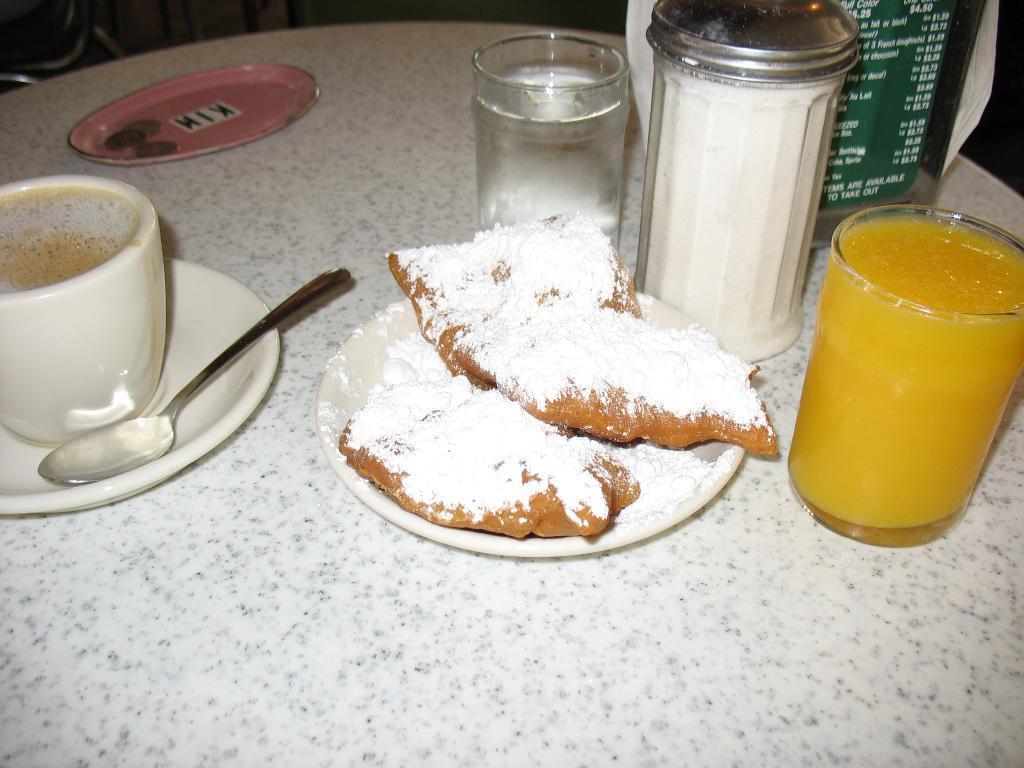Please provide a concise description of this image. This is the table. I can see a glass of juice, plates, a cup of coffee with saucer, spoon, a glass of juice and few other objects on it. This plate contains a food item. 